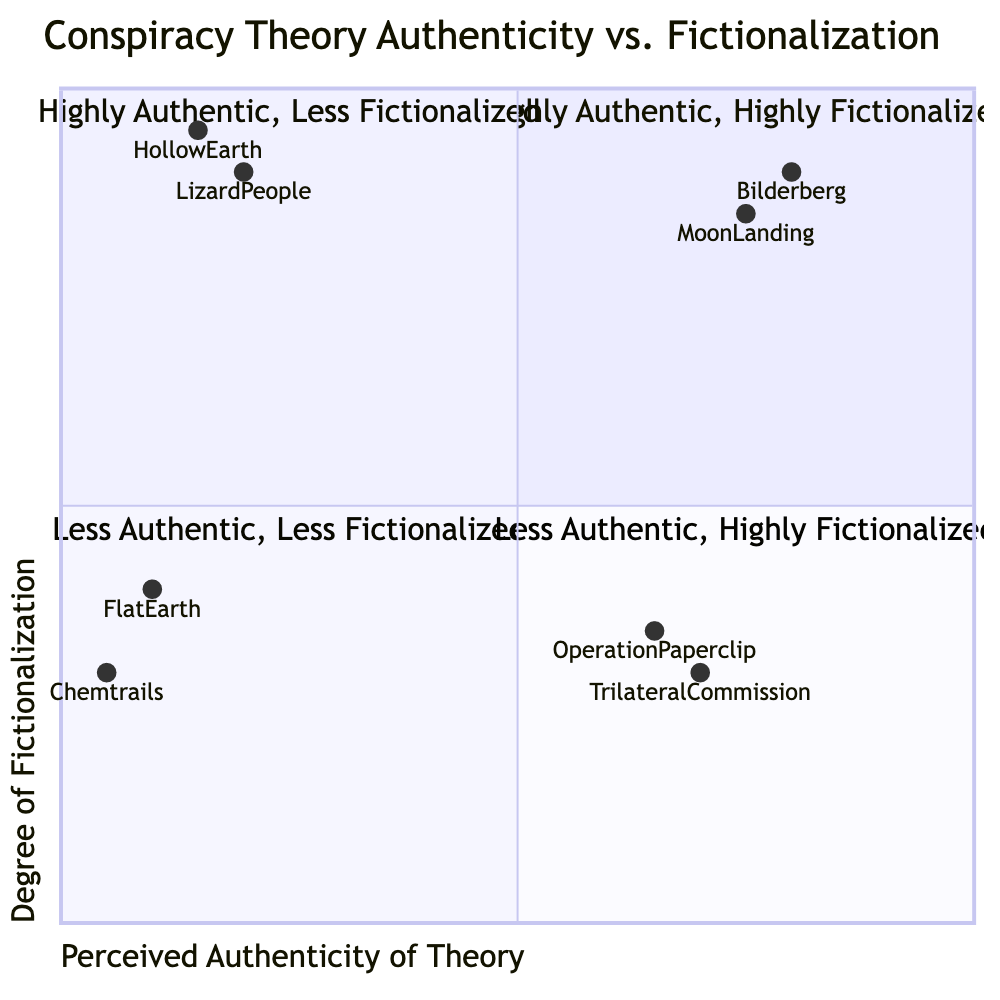What are the examples in the High-High quadrant? The High-High quadrant includes examples that are perceived as highly authentic but also highly fictionalized theories, specifically "The Bilderberg Group as a Secret World Government" and "The Moon Landing Was Filmed in a Studio by Stanley Kubrick."
Answer: The Bilderberg Group as a Secret World Government, The Moon Landing Was Filmed in a Studio by Stanley Kubrick Which example has the lowest perceived authenticity? Among all the examples listed, "Chemtrails as Magical Weather Control" has the lowest score on the X-axis (0.05), indicating the least perceived authenticity.
Answer: Chemtrails as Magical Weather Control How many examples are in the Low-Low quadrant? There are two examples listed in the Low-Low quadrant: "Flat Earth Theory in Fantasy Settings" and "Chemtrails as Magical Weather Control."
Answer: Two What is the perceived authenticity of the "Trilateral Commission Influences Global Politics" theory? The perceived authenticity score for the "Trilateral Commission Influences Global Politics" theory, found in the High-Low quadrant, is 0.7 on the X-axis.
Answer: 0.7 Which quadrant contains examples that are both low in authenticity and high in fictionalization? The Low-High quadrant contains examples that have low perceived authenticity yet are highly fictionalized, such as "Lizard People Control the Government" and "Hollow Earth Theory with Alien Civilizations."
Answer: Low-High What is the degree of fictionalization for the "Operation Paperclip" example? "Operation Paperclip" is classified in the High-Low quadrant and has a degree of fictionalization score of 0.35 on the Y-axis, indicating a relatively low level of fictionalization.
Answer: 0.35 Which example has the highest degree of fictionalization? In the diagram, "Hollow Earth Theory with Alien Civilizations" has the highest degree of fictionalization score of 0.95 in the Low-High quadrant.
Answer: 0.95 What is the position of "Flat Earth Theory in Fantasy Settings" in terms of authenticity and fictionalization? "Flat Earth Theory in Fantasy Settings" is found in the Low-Low quadrant with a perceived authenticity score of 0.1 and a degree of fictionalization score of 0.4, showing both low authenticity and low fictionalization.
Answer: Low-Low 